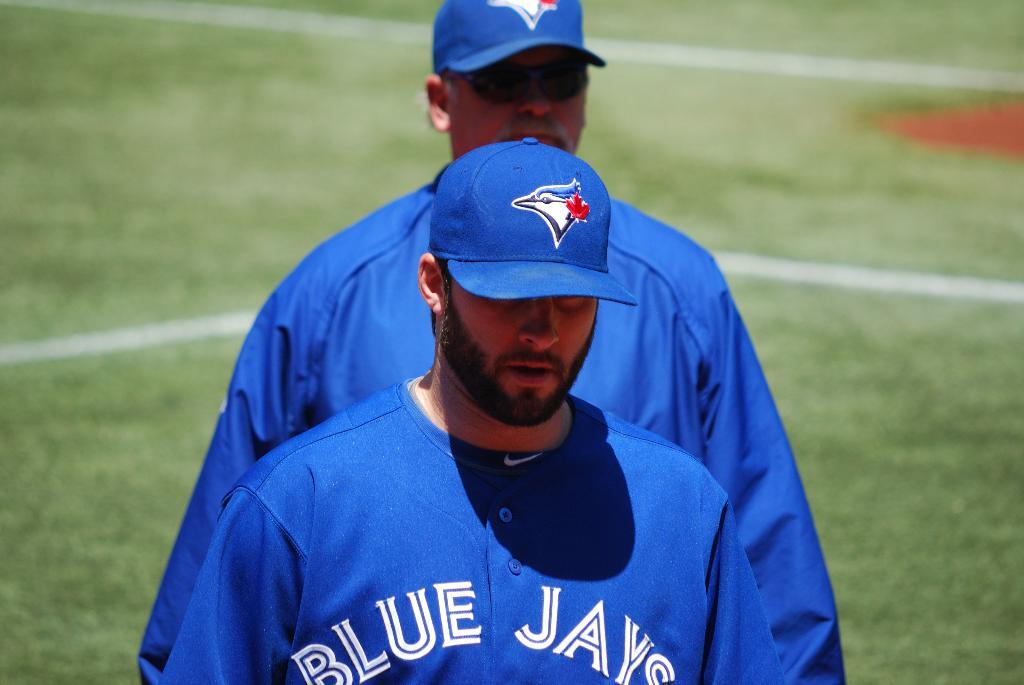<image>
Describe the image concisely. a couple of players that are on the Blue Jays 